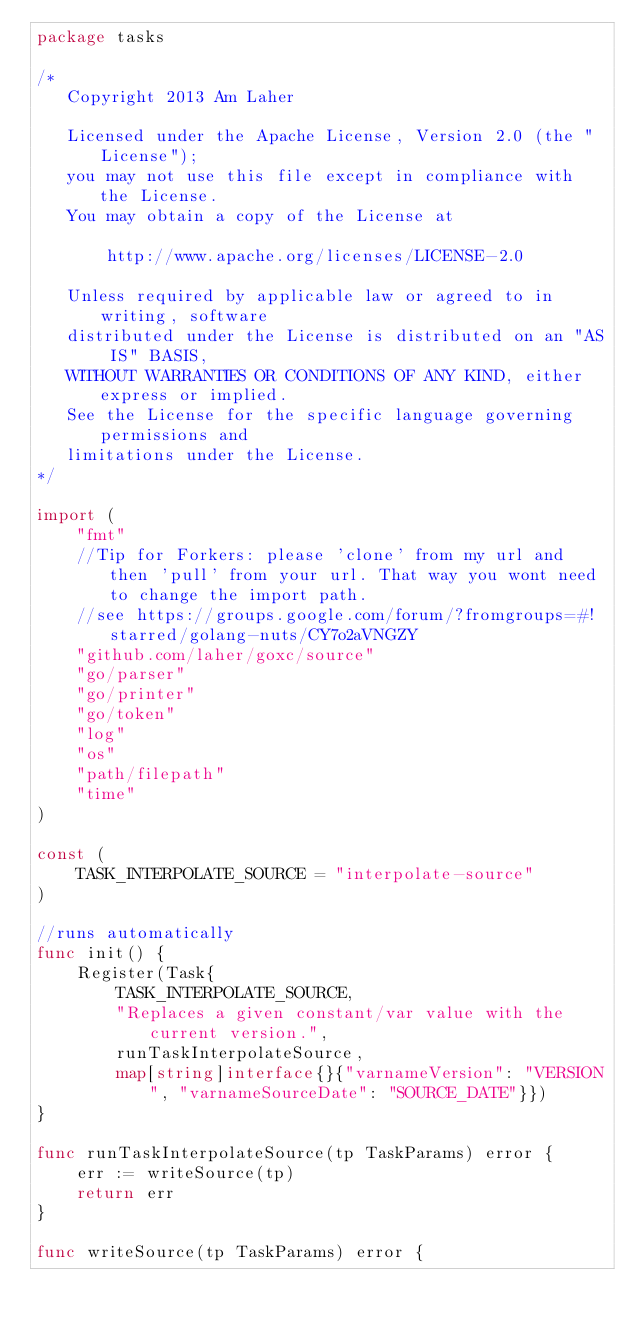Convert code to text. <code><loc_0><loc_0><loc_500><loc_500><_Go_>package tasks

/*
   Copyright 2013 Am Laher

   Licensed under the Apache License, Version 2.0 (the "License");
   you may not use this file except in compliance with the License.
   You may obtain a copy of the License at

       http://www.apache.org/licenses/LICENSE-2.0

   Unless required by applicable law or agreed to in writing, software
   distributed under the License is distributed on an "AS IS" BASIS,
   WITHOUT WARRANTIES OR CONDITIONS OF ANY KIND, either express or implied.
   See the License for the specific language governing permissions and
   limitations under the License.
*/

import (
	"fmt"
	//Tip for Forkers: please 'clone' from my url and then 'pull' from your url. That way you wont need to change the import path.
	//see https://groups.google.com/forum/?fromgroups=#!starred/golang-nuts/CY7o2aVNGZY
	"github.com/laher/goxc/source"
	"go/parser"
	"go/printer"
	"go/token"
	"log"
	"os"
	"path/filepath"
	"time"
)

const (
	TASK_INTERPOLATE_SOURCE = "interpolate-source"
)

//runs automatically
func init() {
	Register(Task{
		TASK_INTERPOLATE_SOURCE,
		"Replaces a given constant/var value with the current version.",
		runTaskInterpolateSource,
		map[string]interface{}{"varnameVersion": "VERSION", "varnameSourceDate": "SOURCE_DATE"}})
}

func runTaskInterpolateSource(tp TaskParams) error {
	err := writeSource(tp)
	return err
}

func writeSource(tp TaskParams) error {
</code> 